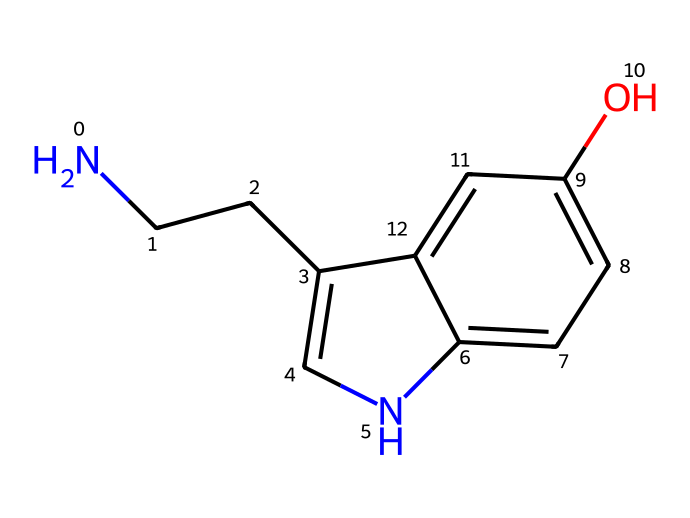What is the molecular formula of serotonin? To determine the molecular formula from the SMILES representation, we count the atoms present. By analyzing the structure, we count: 10 carbon (C), 12 hydrogen (H), 1 nitrogen (N), and 1 oxygen (O), leading to the molecular formula C10H12N2O.
Answer: C10H12N2O How many rings are present in serotonin's structure? Analyzing the SMILES, we observe the 'c' and 'n' characters which indicate aromatic carbon and nitrogen, respectively. The structure depicts two interconnected rings. Therefore, there are two rings present.
Answer: 2 What functional group is indicated by the 'O' in the molecule? The 'O' in the SMILES structure represents an -OH group, known as a hydroxyl group, indicating the presence of phenolic characteristics which contributes to its properties.
Answer: hydroxyl What type of neurotransmitter is serotonin? Serotonin, as indicated in the context of its functions, is categorized as a monoamine neurotransmitter. The presence of an amine (-NH2) along with its biological activity confirms this classification.
Answer: monoamine How does the nitrogen atom influence serotonin's properties? The nitrogen atom in serotonin, specifically part of the amine group, plays a crucial role in its ability to interact with neurotransmitter receptors. This interaction influences mood regulation, as neurotransmitters often require nitrogen in their structure for bonding to receptors.
Answer: neurotransmitter interaction Which part of serotonin contributes to its hydrophilicity? The presence of the hydroxyl group (-OH) in the molecular structure increases the hydrophilicity of serotonin. This functional group can form hydrogen bonds with water, contributing significantly to its solubility.
Answer: hydroxyl group 